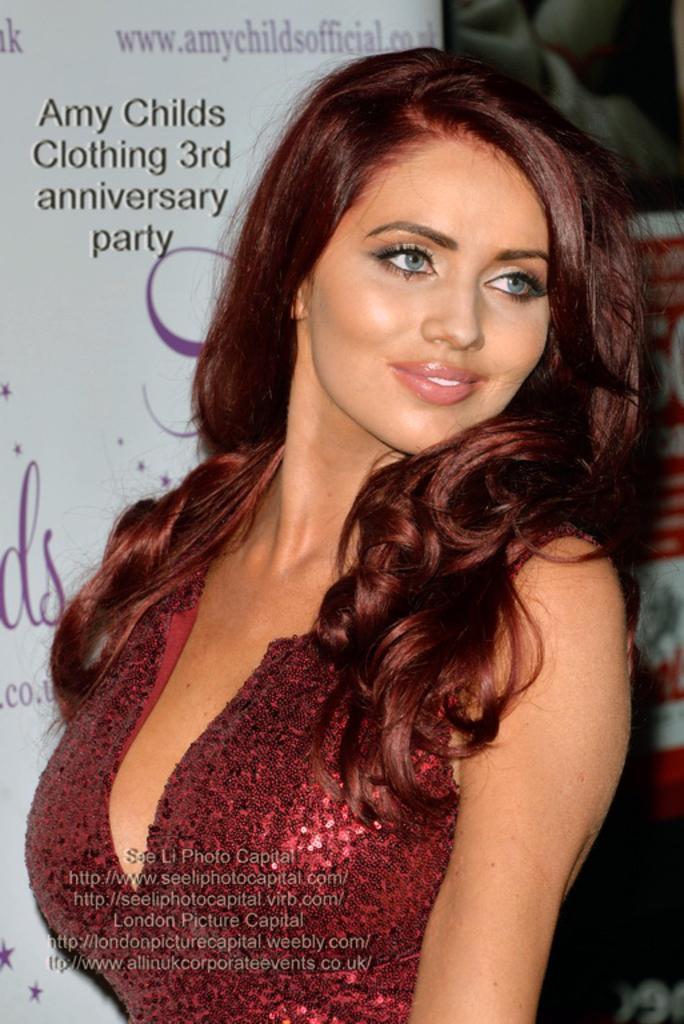Describe this image in one or two sentences. In this image I can see a person standing wearing red color dress. Background I can see a white color banner and something written on it. 